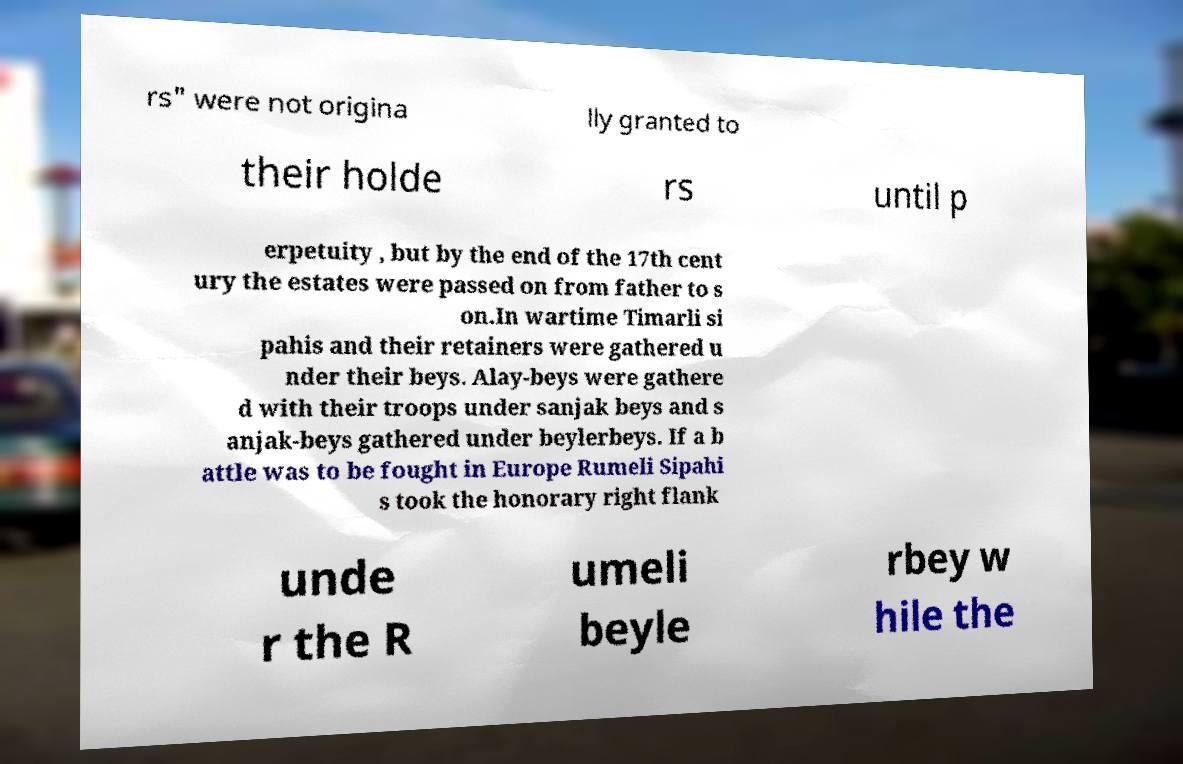Can you accurately transcribe the text from the provided image for me? rs" were not origina lly granted to their holde rs until p erpetuity , but by the end of the 17th cent ury the estates were passed on from father to s on.In wartime Timarli si pahis and their retainers were gathered u nder their beys. Alay-beys were gathere d with their troops under sanjak beys and s anjak-beys gathered under beylerbeys. If a b attle was to be fought in Europe Rumeli Sipahi s took the honorary right flank unde r the R umeli beyle rbey w hile the 